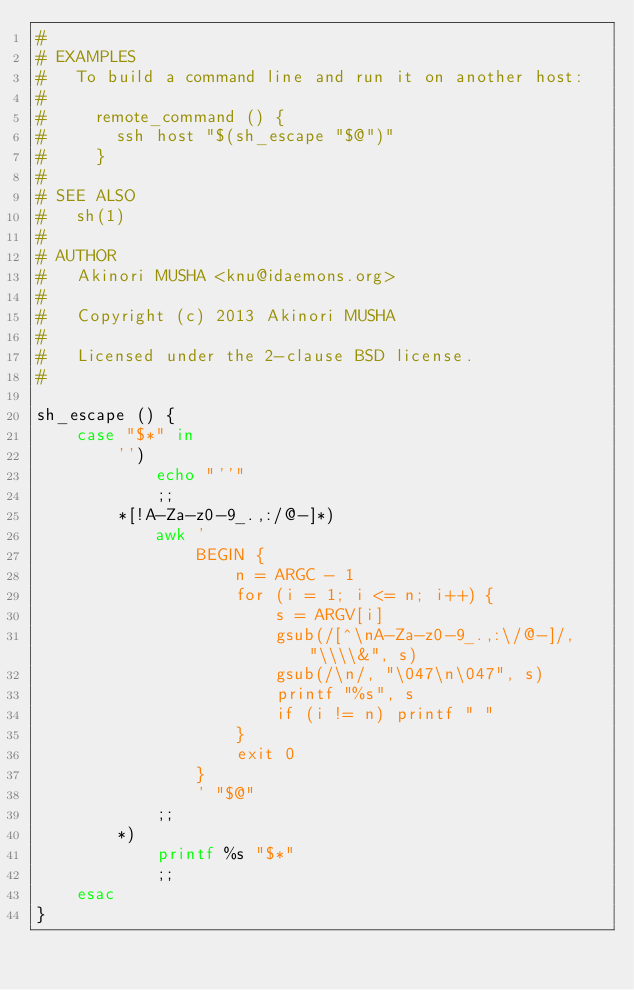Convert code to text. <code><loc_0><loc_0><loc_500><loc_500><_Bash_>#
# EXAMPLES
#   To build a command line and run it on another host:
#
#     remote_command () {
#       ssh host "$(sh_escape "$@")"
#     }
#
# SEE ALSO
#   sh(1)
#
# AUTHOR
#   Akinori MUSHA <knu@idaemons.org>
#
#   Copyright (c) 2013 Akinori MUSHA
#
#   Licensed under the 2-clause BSD license.
#

sh_escape () {
    case "$*" in
        '')
            echo "''"
            ;;
        *[!A-Za-z0-9_.,:/@-]*)
            awk '
                BEGIN {
                    n = ARGC - 1
                    for (i = 1; i <= n; i++) {
                        s = ARGV[i]
                        gsub(/[^\nA-Za-z0-9_.,:\/@-]/, "\\\\&", s)
                        gsub(/\n/, "\047\n\047", s)
                        printf "%s", s
                        if (i != n) printf " "
                    }
                    exit 0
                }
                ' "$@"
            ;;
        *)
            printf %s "$*"
            ;;
    esac
}
</code> 